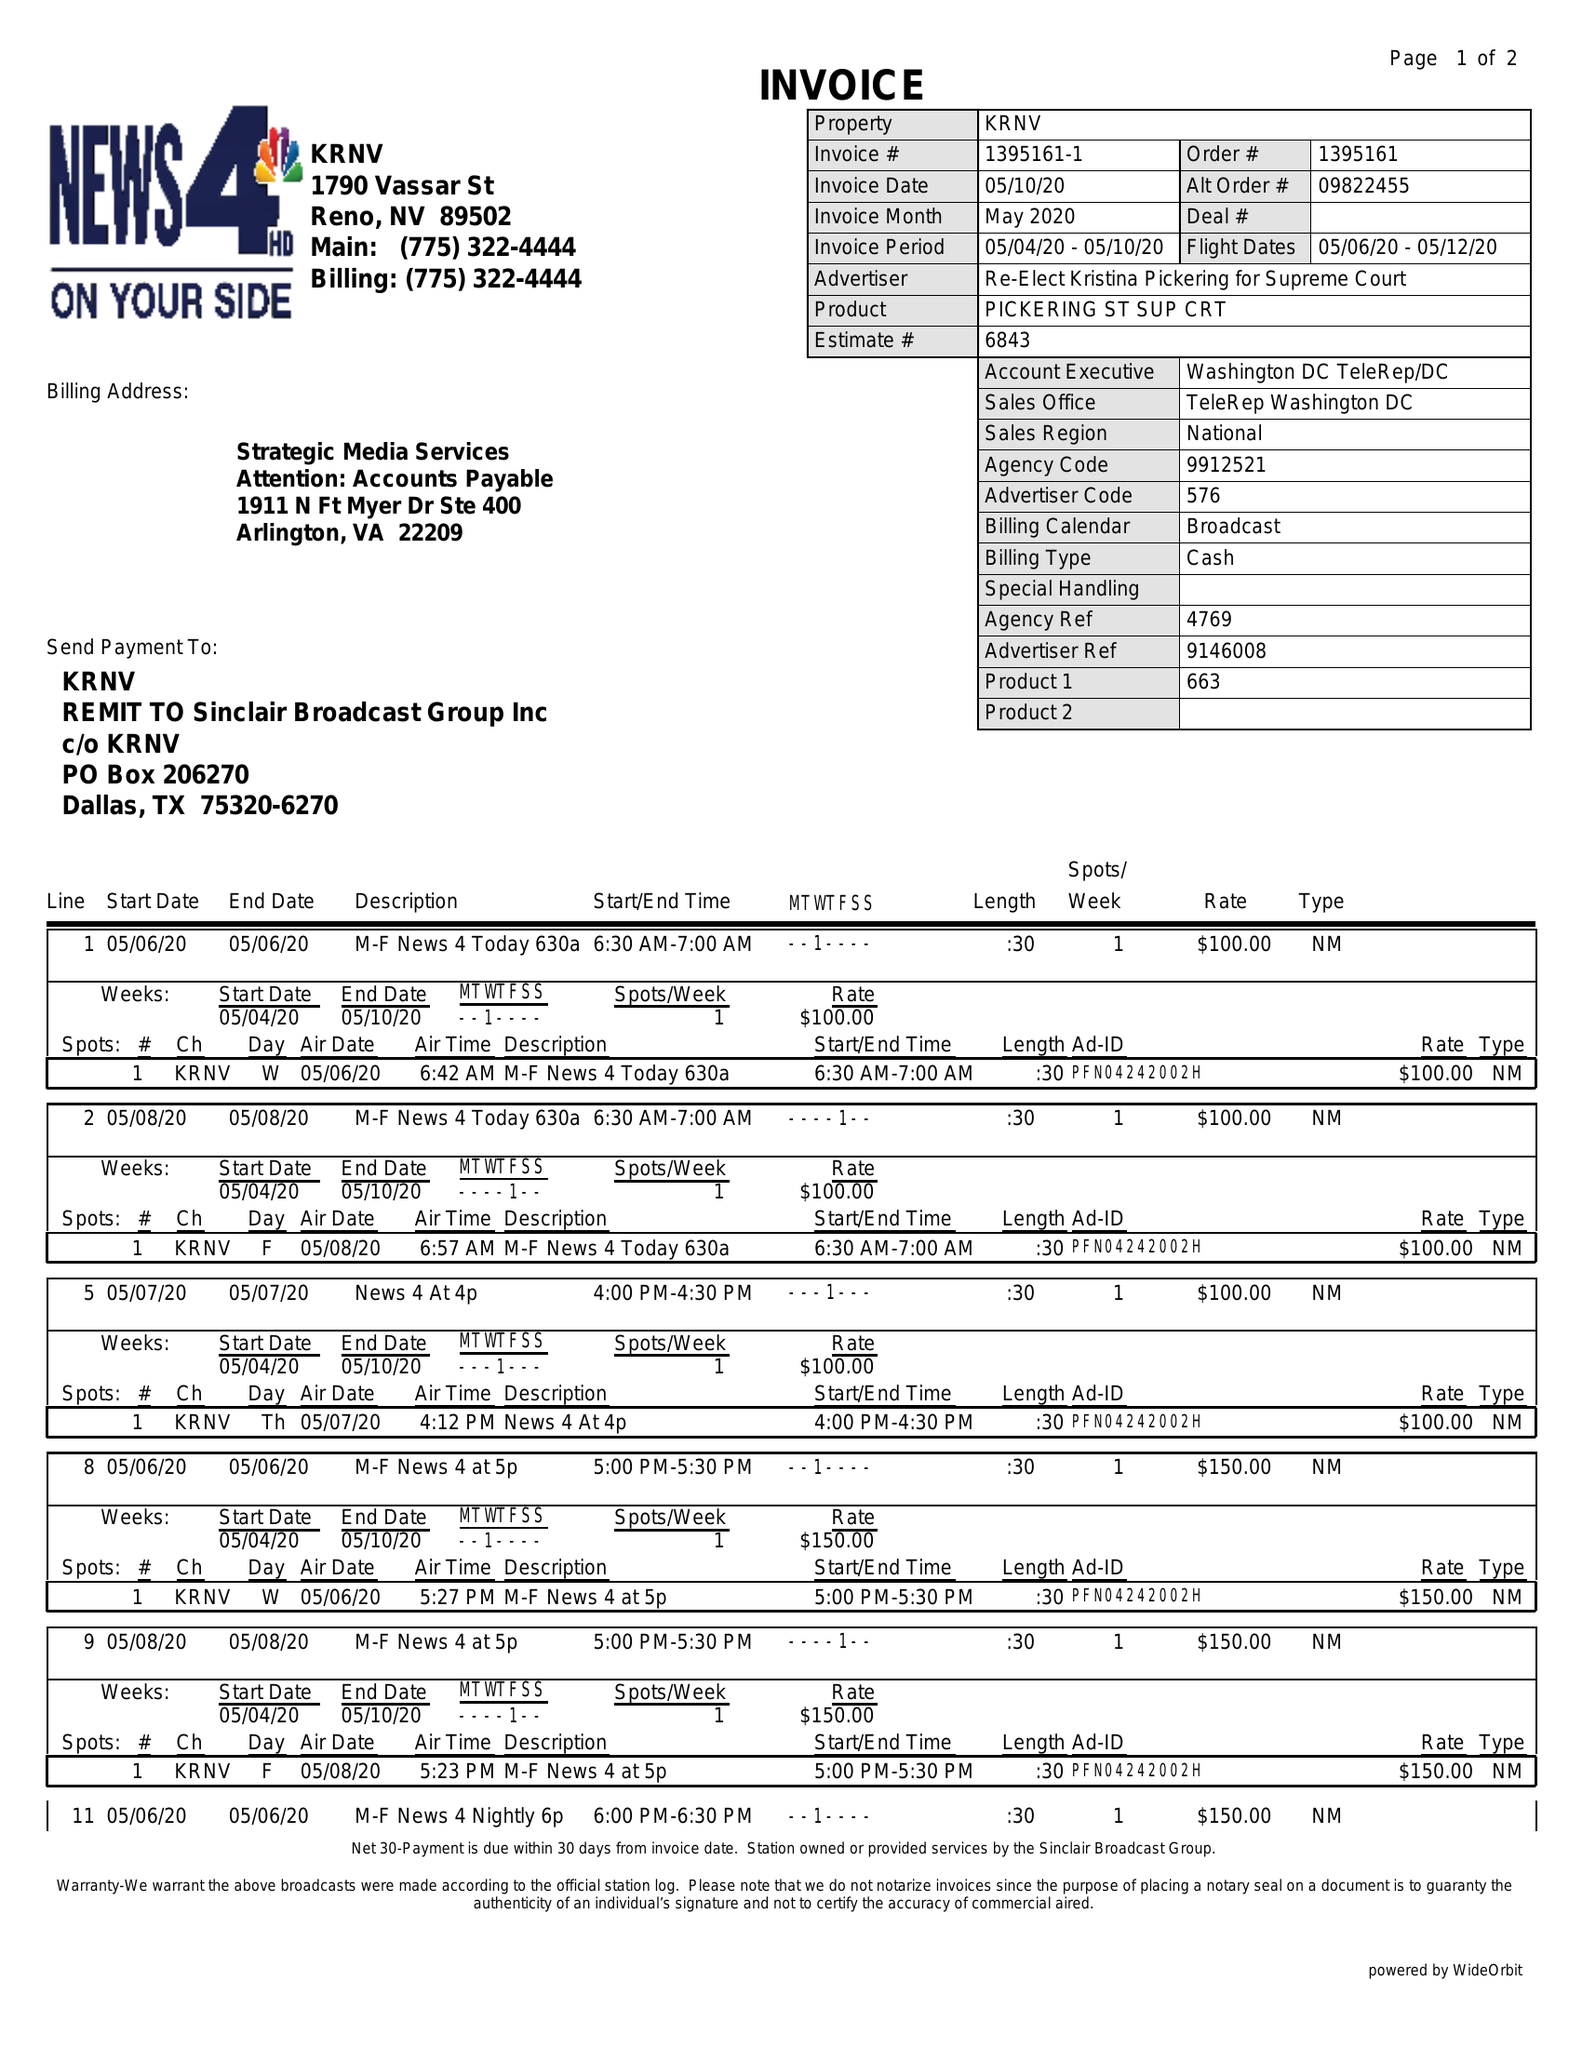What is the value for the flight_to?
Answer the question using a single word or phrase. 05/12/20 